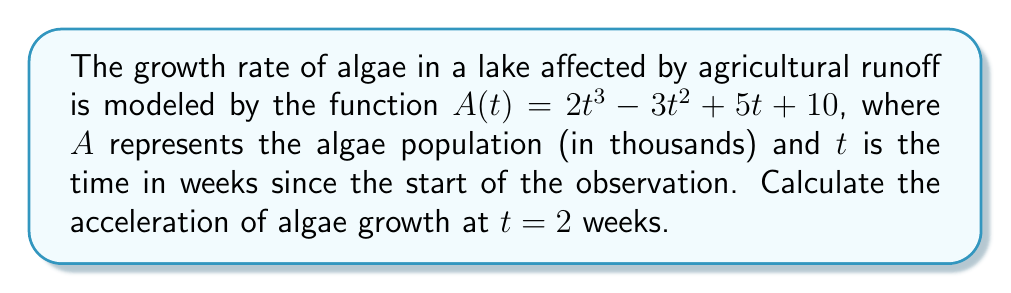Can you solve this math problem? To find the acceleration of algae growth, we need to calculate the second derivative of the function $A(t)$ and evaluate it at $t = 2$. Let's proceed step by step:

1. Given function: $A(t) = 2t^3 - 3t^2 + 5t + 10$

2. First, find the first derivative $A'(t)$:
   $$A'(t) = \frac{d}{dt}(2t^3 - 3t^2 + 5t + 10)$$
   $$A'(t) = 6t^2 - 6t + 5$$

3. Now, find the second derivative $A''(t)$:
   $$A''(t) = \frac{d}{dt}(6t^2 - 6t + 5)$$
   $$A''(t) = 12t - 6$$

4. The second derivative $A''(t)$ represents the acceleration of algae growth.

5. Evaluate $A''(t)$ at $t = 2$:
   $$A''(2) = 12(2) - 6$$
   $$A''(2) = 24 - 6 = 18$$

Therefore, the acceleration of algae growth at $t = 2$ weeks is 18 thousand algae per week^2.
Answer: 18 